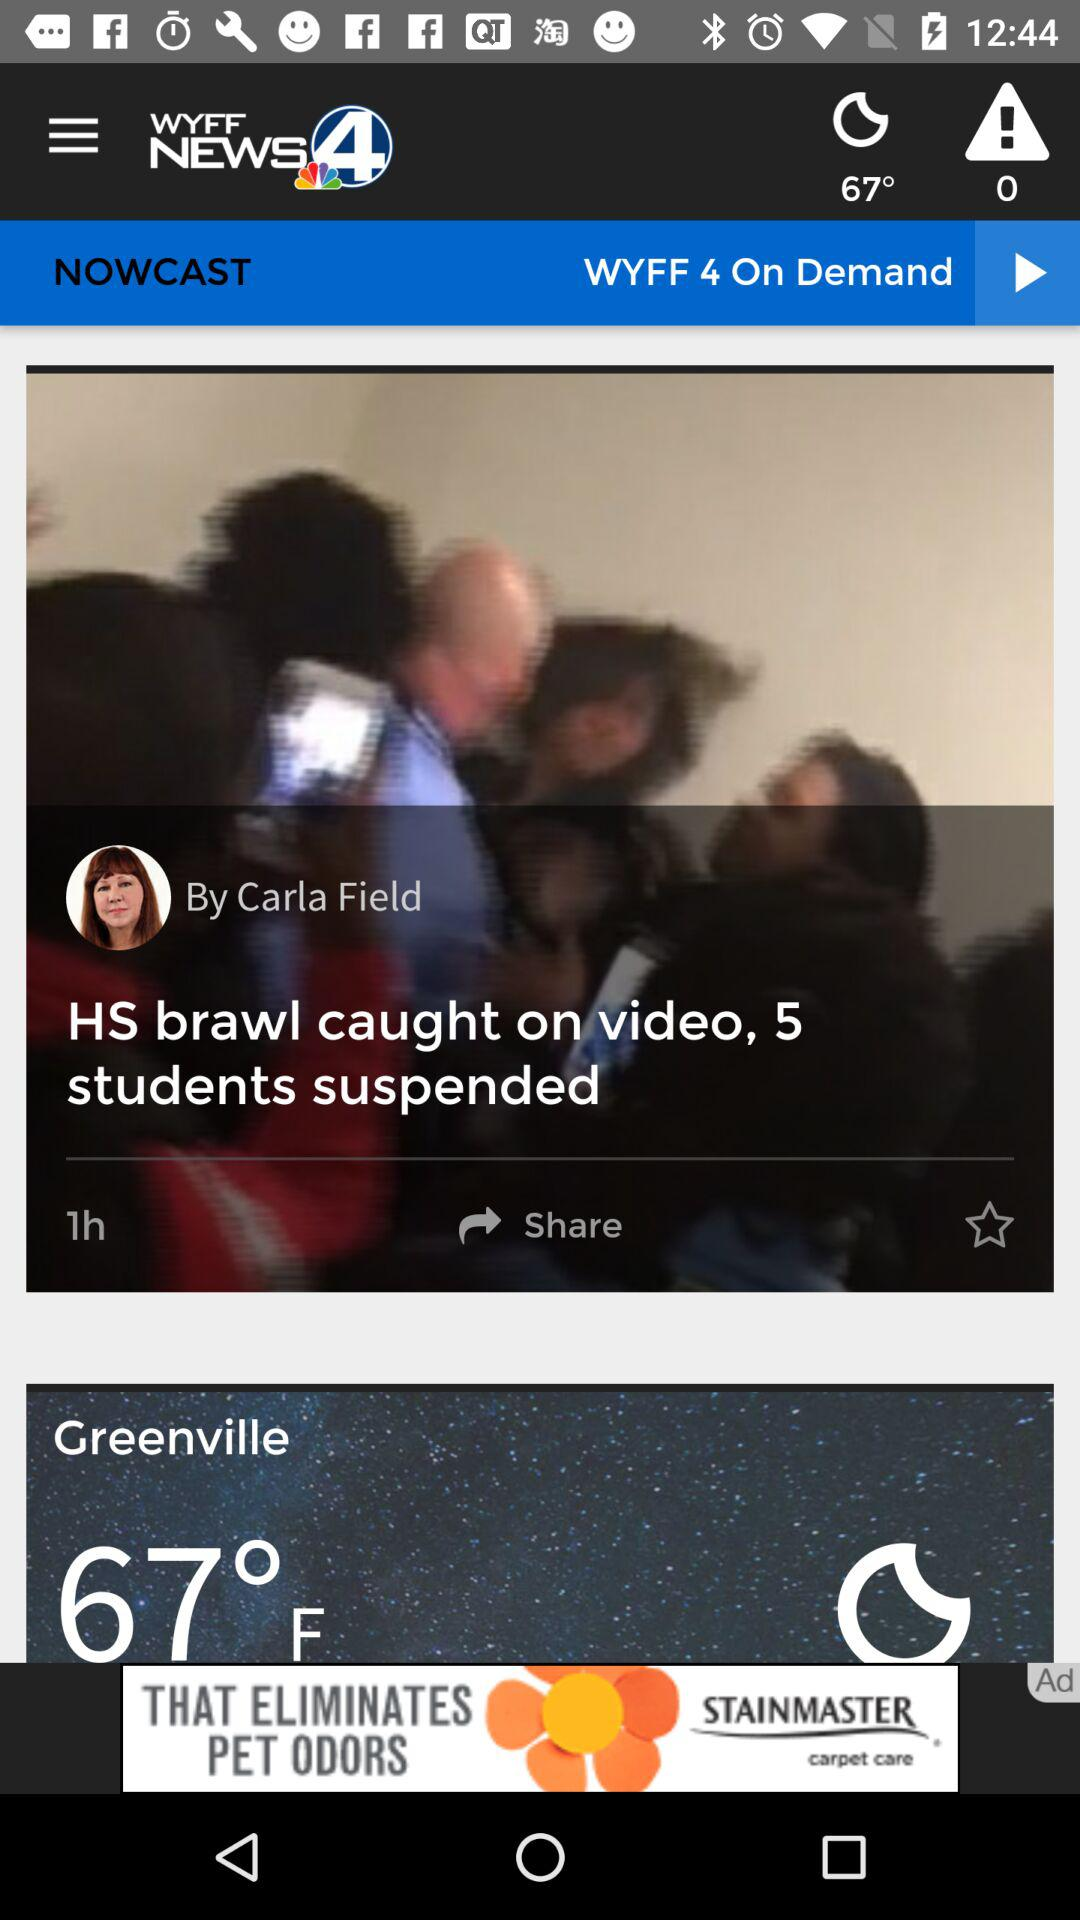What is the application name? The application name is "WYFF". 